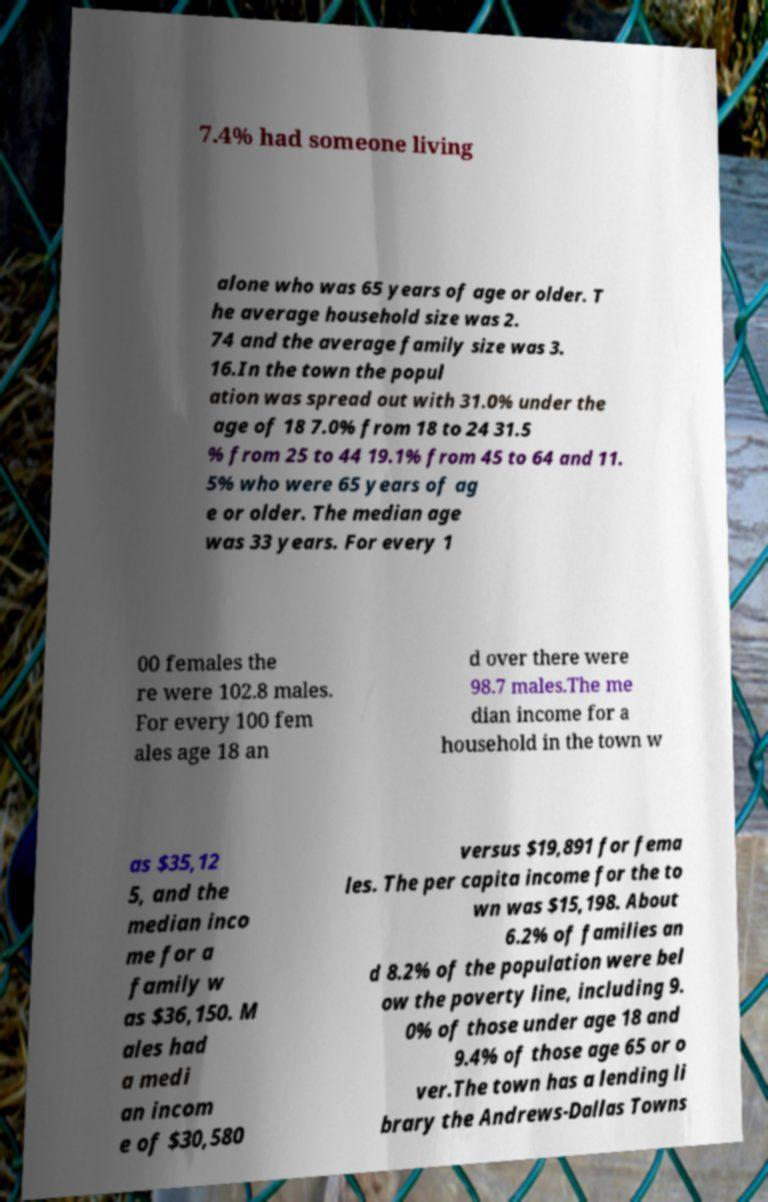There's text embedded in this image that I need extracted. Can you transcribe it verbatim? 7.4% had someone living alone who was 65 years of age or older. T he average household size was 2. 74 and the average family size was 3. 16.In the town the popul ation was spread out with 31.0% under the age of 18 7.0% from 18 to 24 31.5 % from 25 to 44 19.1% from 45 to 64 and 11. 5% who were 65 years of ag e or older. The median age was 33 years. For every 1 00 females the re were 102.8 males. For every 100 fem ales age 18 an d over there were 98.7 males.The me dian income for a household in the town w as $35,12 5, and the median inco me for a family w as $36,150. M ales had a medi an incom e of $30,580 versus $19,891 for fema les. The per capita income for the to wn was $15,198. About 6.2% of families an d 8.2% of the population were bel ow the poverty line, including 9. 0% of those under age 18 and 9.4% of those age 65 or o ver.The town has a lending li brary the Andrews-Dallas Towns 